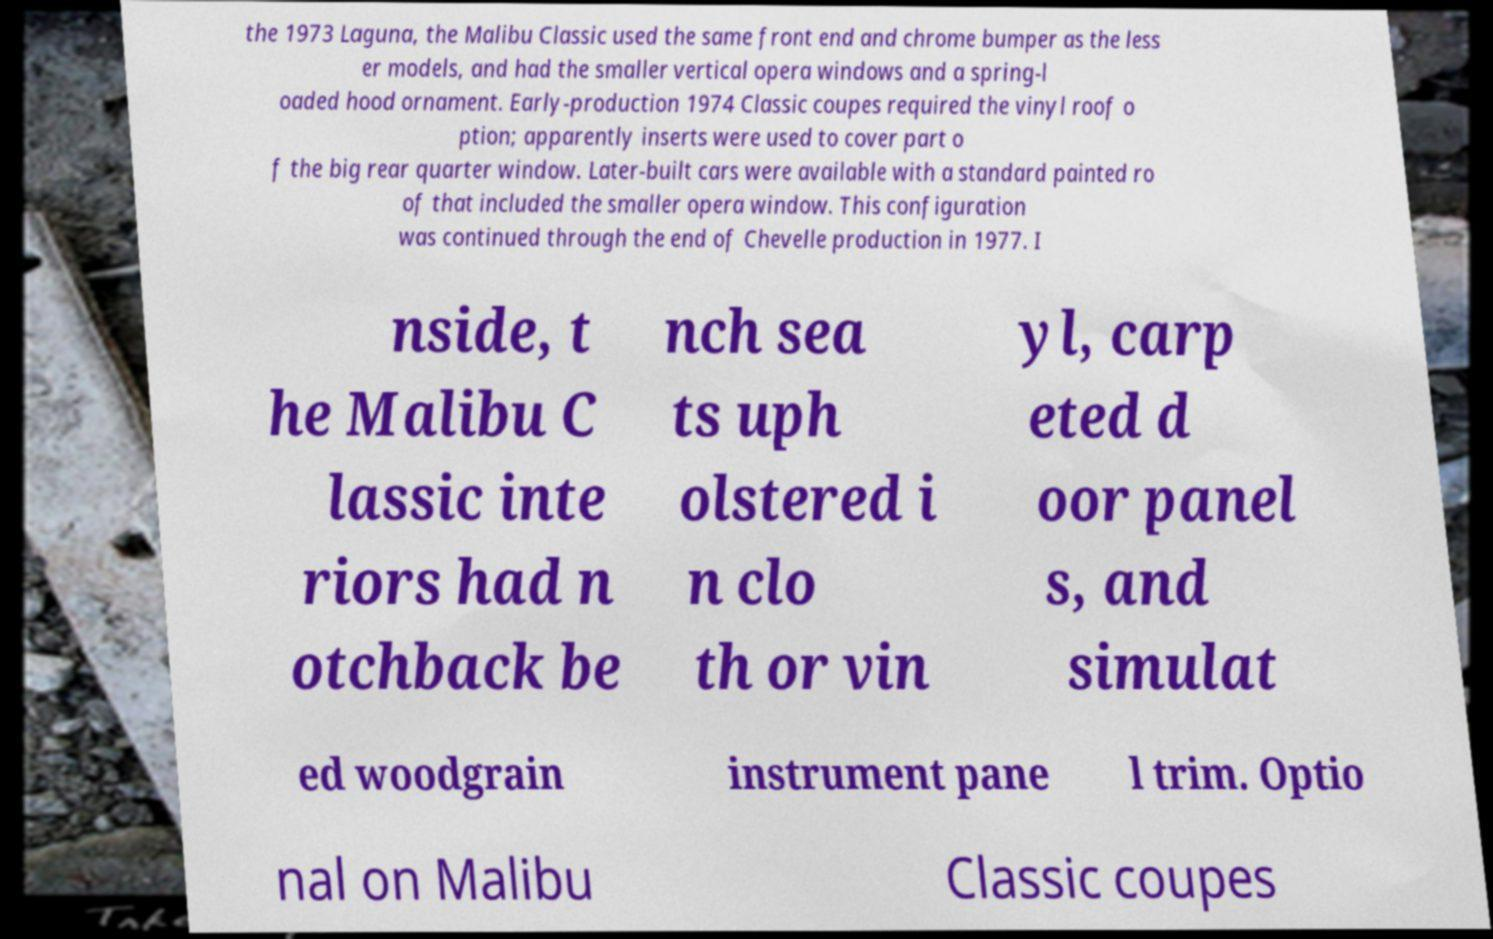For documentation purposes, I need the text within this image transcribed. Could you provide that? the 1973 Laguna, the Malibu Classic used the same front end and chrome bumper as the less er models, and had the smaller vertical opera windows and a spring-l oaded hood ornament. Early-production 1974 Classic coupes required the vinyl roof o ption; apparently inserts were used to cover part o f the big rear quarter window. Later-built cars were available with a standard painted ro of that included the smaller opera window. This configuration was continued through the end of Chevelle production in 1977. I nside, t he Malibu C lassic inte riors had n otchback be nch sea ts uph olstered i n clo th or vin yl, carp eted d oor panel s, and simulat ed woodgrain instrument pane l trim. Optio nal on Malibu Classic coupes 